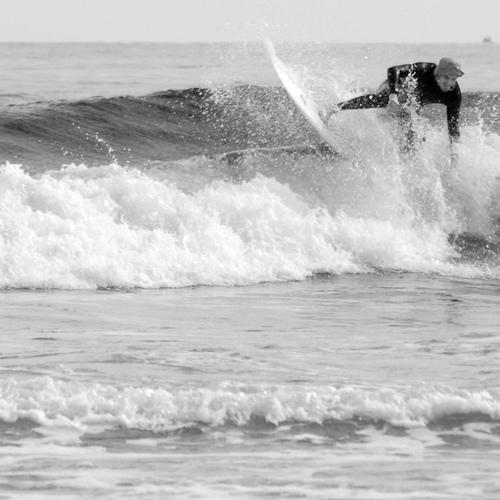How many waves are cresting?
Give a very brief answer. 2. How many feet are on the board?
Give a very brief answer. 2. How many boats are on the horizon?
Give a very brief answer. 1. How many people are surfing?
Give a very brief answer. 1. How many surfboards are shown?
Give a very brief answer. 1. 